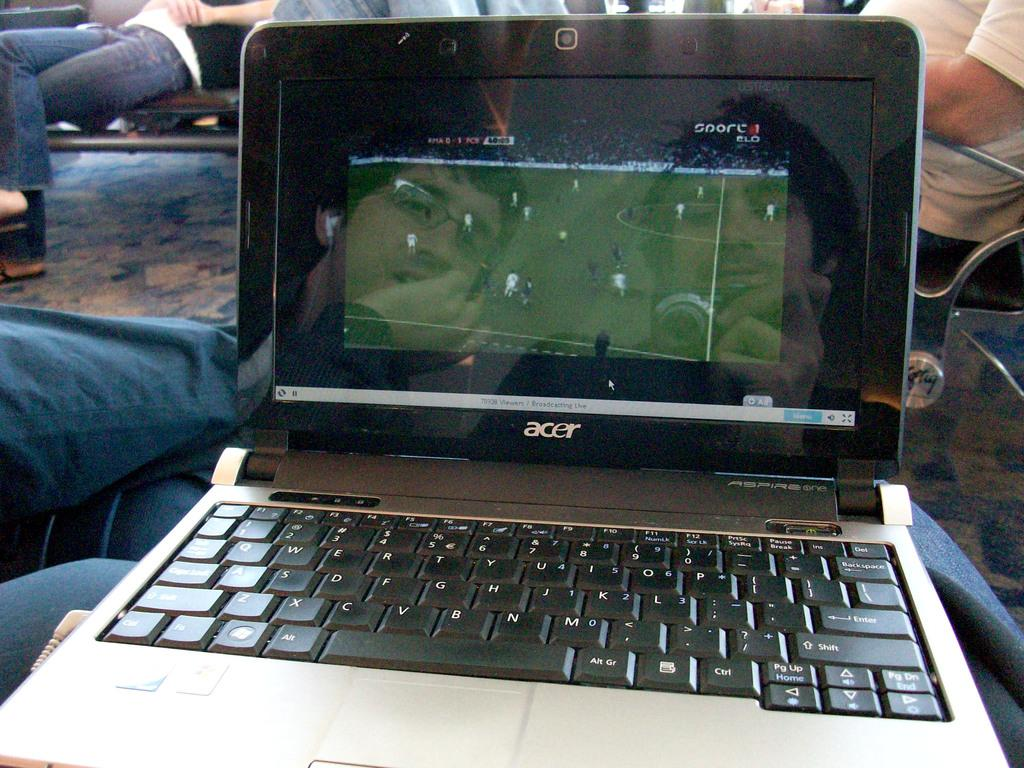<image>
Give a short and clear explanation of the subsequent image. An Acer brand laptop is streaming the soccer match. 